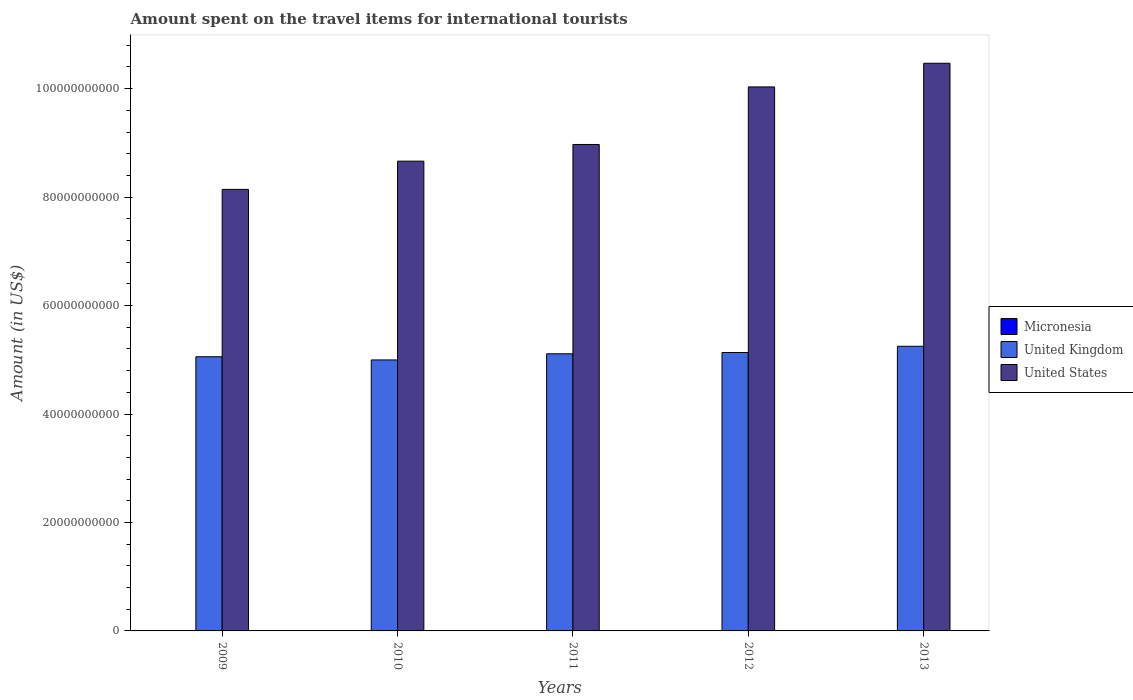How many groups of bars are there?
Provide a short and direct response. 5. How many bars are there on the 1st tick from the right?
Offer a very short reply. 3. In how many cases, is the number of bars for a given year not equal to the number of legend labels?
Provide a succinct answer. 0. What is the amount spent on the travel items for international tourists in United States in 2009?
Your answer should be compact. 8.14e+1. Across all years, what is the maximum amount spent on the travel items for international tourists in United Kingdom?
Your answer should be very brief. 5.25e+1. In which year was the amount spent on the travel items for international tourists in United States maximum?
Give a very brief answer. 2013. In which year was the amount spent on the travel items for international tourists in United Kingdom minimum?
Offer a very short reply. 2010. What is the total amount spent on the travel items for international tourists in United Kingdom in the graph?
Your answer should be compact. 2.55e+11. What is the difference between the amount spent on the travel items for international tourists in Micronesia in 2010 and the amount spent on the travel items for international tourists in United States in 2009?
Give a very brief answer. -8.14e+1. What is the average amount spent on the travel items for international tourists in United States per year?
Give a very brief answer. 9.25e+1. In the year 2009, what is the difference between the amount spent on the travel items for international tourists in United States and amount spent on the travel items for international tourists in United Kingdom?
Provide a succinct answer. 3.09e+1. In how many years, is the amount spent on the travel items for international tourists in United Kingdom greater than 56000000000 US$?
Offer a very short reply. 0. What is the ratio of the amount spent on the travel items for international tourists in United States in 2009 to that in 2010?
Offer a very short reply. 0.94. Is the amount spent on the travel items for international tourists in United Kingdom in 2009 less than that in 2013?
Keep it short and to the point. Yes. Is the difference between the amount spent on the travel items for international tourists in United States in 2011 and 2013 greater than the difference between the amount spent on the travel items for international tourists in United Kingdom in 2011 and 2013?
Keep it short and to the point. No. What is the difference between the highest and the second highest amount spent on the travel items for international tourists in United Kingdom?
Make the answer very short. 1.15e+09. What is the difference between the highest and the lowest amount spent on the travel items for international tourists in United Kingdom?
Provide a short and direct response. 2.52e+09. In how many years, is the amount spent on the travel items for international tourists in United States greater than the average amount spent on the travel items for international tourists in United States taken over all years?
Keep it short and to the point. 2. What does the 2nd bar from the left in 2011 represents?
Provide a succinct answer. United Kingdom. What does the 2nd bar from the right in 2010 represents?
Your answer should be compact. United Kingdom. How many years are there in the graph?
Make the answer very short. 5. What is the difference between two consecutive major ticks on the Y-axis?
Offer a terse response. 2.00e+1. Where does the legend appear in the graph?
Provide a succinct answer. Center right. How many legend labels are there?
Your answer should be compact. 3. How are the legend labels stacked?
Your response must be concise. Vertical. What is the title of the graph?
Your answer should be compact. Amount spent on the travel items for international tourists. Does "Slovak Republic" appear as one of the legend labels in the graph?
Offer a very short reply. No. What is the label or title of the X-axis?
Give a very brief answer. Years. What is the label or title of the Y-axis?
Provide a short and direct response. Amount (in US$). What is the Amount (in US$) in United Kingdom in 2009?
Your response must be concise. 5.06e+1. What is the Amount (in US$) of United States in 2009?
Your answer should be compact. 8.14e+1. What is the Amount (in US$) in Micronesia in 2010?
Offer a very short reply. 1.20e+07. What is the Amount (in US$) of United Kingdom in 2010?
Give a very brief answer. 5.00e+1. What is the Amount (in US$) in United States in 2010?
Your answer should be very brief. 8.66e+1. What is the Amount (in US$) in Micronesia in 2011?
Your answer should be compact. 1.20e+07. What is the Amount (in US$) of United Kingdom in 2011?
Your response must be concise. 5.11e+1. What is the Amount (in US$) of United States in 2011?
Your response must be concise. 8.97e+1. What is the Amount (in US$) in Micronesia in 2012?
Offer a terse response. 1.30e+07. What is the Amount (in US$) in United Kingdom in 2012?
Offer a terse response. 5.13e+1. What is the Amount (in US$) of United States in 2012?
Provide a short and direct response. 1.00e+11. What is the Amount (in US$) in Micronesia in 2013?
Give a very brief answer. 1.20e+07. What is the Amount (in US$) of United Kingdom in 2013?
Offer a very short reply. 5.25e+1. What is the Amount (in US$) in United States in 2013?
Your answer should be very brief. 1.05e+11. Across all years, what is the maximum Amount (in US$) of Micronesia?
Make the answer very short. 1.30e+07. Across all years, what is the maximum Amount (in US$) in United Kingdom?
Provide a short and direct response. 5.25e+1. Across all years, what is the maximum Amount (in US$) of United States?
Your answer should be compact. 1.05e+11. Across all years, what is the minimum Amount (in US$) of Micronesia?
Your answer should be compact. 1.00e+07. Across all years, what is the minimum Amount (in US$) in United Kingdom?
Your answer should be compact. 5.00e+1. Across all years, what is the minimum Amount (in US$) in United States?
Offer a terse response. 8.14e+1. What is the total Amount (in US$) in Micronesia in the graph?
Your response must be concise. 5.90e+07. What is the total Amount (in US$) of United Kingdom in the graph?
Your answer should be compact. 2.55e+11. What is the total Amount (in US$) of United States in the graph?
Ensure brevity in your answer.  4.63e+11. What is the difference between the Amount (in US$) in United Kingdom in 2009 and that in 2010?
Your answer should be compact. 5.87e+08. What is the difference between the Amount (in US$) of United States in 2009 and that in 2010?
Provide a short and direct response. -5.20e+09. What is the difference between the Amount (in US$) in Micronesia in 2009 and that in 2011?
Your answer should be compact. -2.00e+06. What is the difference between the Amount (in US$) in United Kingdom in 2009 and that in 2011?
Make the answer very short. -5.46e+08. What is the difference between the Amount (in US$) in United States in 2009 and that in 2011?
Keep it short and to the point. -8.28e+09. What is the difference between the Amount (in US$) in United Kingdom in 2009 and that in 2012?
Offer a very short reply. -7.82e+08. What is the difference between the Amount (in US$) in United States in 2009 and that in 2012?
Give a very brief answer. -1.89e+1. What is the difference between the Amount (in US$) of Micronesia in 2009 and that in 2013?
Your response must be concise. -2.00e+06. What is the difference between the Amount (in US$) in United Kingdom in 2009 and that in 2013?
Ensure brevity in your answer.  -1.93e+09. What is the difference between the Amount (in US$) in United States in 2009 and that in 2013?
Give a very brief answer. -2.33e+1. What is the difference between the Amount (in US$) in United Kingdom in 2010 and that in 2011?
Your answer should be compact. -1.13e+09. What is the difference between the Amount (in US$) in United States in 2010 and that in 2011?
Provide a succinct answer. -3.08e+09. What is the difference between the Amount (in US$) in United Kingdom in 2010 and that in 2012?
Offer a terse response. -1.37e+09. What is the difference between the Amount (in US$) of United States in 2010 and that in 2012?
Your answer should be very brief. -1.37e+1. What is the difference between the Amount (in US$) in United Kingdom in 2010 and that in 2013?
Your answer should be compact. -2.52e+09. What is the difference between the Amount (in US$) of United States in 2010 and that in 2013?
Ensure brevity in your answer.  -1.81e+1. What is the difference between the Amount (in US$) of Micronesia in 2011 and that in 2012?
Offer a terse response. -1.00e+06. What is the difference between the Amount (in US$) in United Kingdom in 2011 and that in 2012?
Offer a terse response. -2.36e+08. What is the difference between the Amount (in US$) of United States in 2011 and that in 2012?
Make the answer very short. -1.06e+1. What is the difference between the Amount (in US$) in Micronesia in 2011 and that in 2013?
Offer a very short reply. 0. What is the difference between the Amount (in US$) in United Kingdom in 2011 and that in 2013?
Your response must be concise. -1.38e+09. What is the difference between the Amount (in US$) of United States in 2011 and that in 2013?
Your answer should be very brief. -1.50e+1. What is the difference between the Amount (in US$) of Micronesia in 2012 and that in 2013?
Offer a very short reply. 1.00e+06. What is the difference between the Amount (in US$) in United Kingdom in 2012 and that in 2013?
Make the answer very short. -1.15e+09. What is the difference between the Amount (in US$) of United States in 2012 and that in 2013?
Your response must be concise. -4.36e+09. What is the difference between the Amount (in US$) of Micronesia in 2009 and the Amount (in US$) of United Kingdom in 2010?
Offer a very short reply. -5.00e+1. What is the difference between the Amount (in US$) in Micronesia in 2009 and the Amount (in US$) in United States in 2010?
Provide a succinct answer. -8.66e+1. What is the difference between the Amount (in US$) of United Kingdom in 2009 and the Amount (in US$) of United States in 2010?
Ensure brevity in your answer.  -3.61e+1. What is the difference between the Amount (in US$) in Micronesia in 2009 and the Amount (in US$) in United Kingdom in 2011?
Make the answer very short. -5.11e+1. What is the difference between the Amount (in US$) in Micronesia in 2009 and the Amount (in US$) in United States in 2011?
Provide a short and direct response. -8.97e+1. What is the difference between the Amount (in US$) in United Kingdom in 2009 and the Amount (in US$) in United States in 2011?
Give a very brief answer. -3.91e+1. What is the difference between the Amount (in US$) in Micronesia in 2009 and the Amount (in US$) in United Kingdom in 2012?
Make the answer very short. -5.13e+1. What is the difference between the Amount (in US$) of Micronesia in 2009 and the Amount (in US$) of United States in 2012?
Offer a terse response. -1.00e+11. What is the difference between the Amount (in US$) in United Kingdom in 2009 and the Amount (in US$) in United States in 2012?
Your answer should be compact. -4.98e+1. What is the difference between the Amount (in US$) in Micronesia in 2009 and the Amount (in US$) in United Kingdom in 2013?
Your answer should be very brief. -5.25e+1. What is the difference between the Amount (in US$) of Micronesia in 2009 and the Amount (in US$) of United States in 2013?
Provide a short and direct response. -1.05e+11. What is the difference between the Amount (in US$) of United Kingdom in 2009 and the Amount (in US$) of United States in 2013?
Your answer should be compact. -5.41e+1. What is the difference between the Amount (in US$) of Micronesia in 2010 and the Amount (in US$) of United Kingdom in 2011?
Your response must be concise. -5.11e+1. What is the difference between the Amount (in US$) in Micronesia in 2010 and the Amount (in US$) in United States in 2011?
Provide a short and direct response. -8.97e+1. What is the difference between the Amount (in US$) in United Kingdom in 2010 and the Amount (in US$) in United States in 2011?
Give a very brief answer. -3.97e+1. What is the difference between the Amount (in US$) of Micronesia in 2010 and the Amount (in US$) of United Kingdom in 2012?
Make the answer very short. -5.13e+1. What is the difference between the Amount (in US$) of Micronesia in 2010 and the Amount (in US$) of United States in 2012?
Give a very brief answer. -1.00e+11. What is the difference between the Amount (in US$) in United Kingdom in 2010 and the Amount (in US$) in United States in 2012?
Your response must be concise. -5.03e+1. What is the difference between the Amount (in US$) of Micronesia in 2010 and the Amount (in US$) of United Kingdom in 2013?
Your response must be concise. -5.25e+1. What is the difference between the Amount (in US$) in Micronesia in 2010 and the Amount (in US$) in United States in 2013?
Your answer should be very brief. -1.05e+11. What is the difference between the Amount (in US$) of United Kingdom in 2010 and the Amount (in US$) of United States in 2013?
Keep it short and to the point. -5.47e+1. What is the difference between the Amount (in US$) of Micronesia in 2011 and the Amount (in US$) of United Kingdom in 2012?
Provide a succinct answer. -5.13e+1. What is the difference between the Amount (in US$) of Micronesia in 2011 and the Amount (in US$) of United States in 2012?
Your answer should be very brief. -1.00e+11. What is the difference between the Amount (in US$) in United Kingdom in 2011 and the Amount (in US$) in United States in 2012?
Your response must be concise. -4.92e+1. What is the difference between the Amount (in US$) in Micronesia in 2011 and the Amount (in US$) in United Kingdom in 2013?
Your answer should be compact. -5.25e+1. What is the difference between the Amount (in US$) in Micronesia in 2011 and the Amount (in US$) in United States in 2013?
Provide a succinct answer. -1.05e+11. What is the difference between the Amount (in US$) of United Kingdom in 2011 and the Amount (in US$) of United States in 2013?
Ensure brevity in your answer.  -5.36e+1. What is the difference between the Amount (in US$) of Micronesia in 2012 and the Amount (in US$) of United Kingdom in 2013?
Your answer should be very brief. -5.25e+1. What is the difference between the Amount (in US$) in Micronesia in 2012 and the Amount (in US$) in United States in 2013?
Give a very brief answer. -1.05e+11. What is the difference between the Amount (in US$) of United Kingdom in 2012 and the Amount (in US$) of United States in 2013?
Ensure brevity in your answer.  -5.33e+1. What is the average Amount (in US$) in Micronesia per year?
Ensure brevity in your answer.  1.18e+07. What is the average Amount (in US$) of United Kingdom per year?
Provide a succinct answer. 5.11e+1. What is the average Amount (in US$) of United States per year?
Your answer should be compact. 9.25e+1. In the year 2009, what is the difference between the Amount (in US$) of Micronesia and Amount (in US$) of United Kingdom?
Offer a very short reply. -5.05e+1. In the year 2009, what is the difference between the Amount (in US$) in Micronesia and Amount (in US$) in United States?
Your answer should be very brief. -8.14e+1. In the year 2009, what is the difference between the Amount (in US$) of United Kingdom and Amount (in US$) of United States?
Ensure brevity in your answer.  -3.09e+1. In the year 2010, what is the difference between the Amount (in US$) of Micronesia and Amount (in US$) of United Kingdom?
Your answer should be compact. -5.00e+1. In the year 2010, what is the difference between the Amount (in US$) in Micronesia and Amount (in US$) in United States?
Your response must be concise. -8.66e+1. In the year 2010, what is the difference between the Amount (in US$) of United Kingdom and Amount (in US$) of United States?
Ensure brevity in your answer.  -3.67e+1. In the year 2011, what is the difference between the Amount (in US$) of Micronesia and Amount (in US$) of United Kingdom?
Your answer should be compact. -5.11e+1. In the year 2011, what is the difference between the Amount (in US$) in Micronesia and Amount (in US$) in United States?
Offer a terse response. -8.97e+1. In the year 2011, what is the difference between the Amount (in US$) of United Kingdom and Amount (in US$) of United States?
Give a very brief answer. -3.86e+1. In the year 2012, what is the difference between the Amount (in US$) of Micronesia and Amount (in US$) of United Kingdom?
Offer a terse response. -5.13e+1. In the year 2012, what is the difference between the Amount (in US$) in Micronesia and Amount (in US$) in United States?
Give a very brief answer. -1.00e+11. In the year 2012, what is the difference between the Amount (in US$) in United Kingdom and Amount (in US$) in United States?
Ensure brevity in your answer.  -4.90e+1. In the year 2013, what is the difference between the Amount (in US$) of Micronesia and Amount (in US$) of United Kingdom?
Your answer should be very brief. -5.25e+1. In the year 2013, what is the difference between the Amount (in US$) of Micronesia and Amount (in US$) of United States?
Make the answer very short. -1.05e+11. In the year 2013, what is the difference between the Amount (in US$) of United Kingdom and Amount (in US$) of United States?
Your response must be concise. -5.22e+1. What is the ratio of the Amount (in US$) of United Kingdom in 2009 to that in 2010?
Provide a short and direct response. 1.01. What is the ratio of the Amount (in US$) in United States in 2009 to that in 2010?
Your answer should be very brief. 0.94. What is the ratio of the Amount (in US$) of United Kingdom in 2009 to that in 2011?
Offer a terse response. 0.99. What is the ratio of the Amount (in US$) in United States in 2009 to that in 2011?
Give a very brief answer. 0.91. What is the ratio of the Amount (in US$) of Micronesia in 2009 to that in 2012?
Your answer should be very brief. 0.77. What is the ratio of the Amount (in US$) of United States in 2009 to that in 2012?
Your response must be concise. 0.81. What is the ratio of the Amount (in US$) of United Kingdom in 2009 to that in 2013?
Offer a terse response. 0.96. What is the ratio of the Amount (in US$) of Micronesia in 2010 to that in 2011?
Provide a succinct answer. 1. What is the ratio of the Amount (in US$) of United Kingdom in 2010 to that in 2011?
Your answer should be compact. 0.98. What is the ratio of the Amount (in US$) in United States in 2010 to that in 2011?
Offer a terse response. 0.97. What is the ratio of the Amount (in US$) in Micronesia in 2010 to that in 2012?
Ensure brevity in your answer.  0.92. What is the ratio of the Amount (in US$) of United Kingdom in 2010 to that in 2012?
Your response must be concise. 0.97. What is the ratio of the Amount (in US$) in United States in 2010 to that in 2012?
Offer a very short reply. 0.86. What is the ratio of the Amount (in US$) in Micronesia in 2010 to that in 2013?
Offer a terse response. 1. What is the ratio of the Amount (in US$) in United States in 2010 to that in 2013?
Provide a short and direct response. 0.83. What is the ratio of the Amount (in US$) in United States in 2011 to that in 2012?
Provide a short and direct response. 0.89. What is the ratio of the Amount (in US$) of Micronesia in 2011 to that in 2013?
Make the answer very short. 1. What is the ratio of the Amount (in US$) in United Kingdom in 2011 to that in 2013?
Provide a short and direct response. 0.97. What is the ratio of the Amount (in US$) in United States in 2011 to that in 2013?
Offer a terse response. 0.86. What is the ratio of the Amount (in US$) in United Kingdom in 2012 to that in 2013?
Your response must be concise. 0.98. What is the difference between the highest and the second highest Amount (in US$) of United Kingdom?
Give a very brief answer. 1.15e+09. What is the difference between the highest and the second highest Amount (in US$) of United States?
Provide a succinct answer. 4.36e+09. What is the difference between the highest and the lowest Amount (in US$) of Micronesia?
Keep it short and to the point. 3.00e+06. What is the difference between the highest and the lowest Amount (in US$) of United Kingdom?
Keep it short and to the point. 2.52e+09. What is the difference between the highest and the lowest Amount (in US$) in United States?
Keep it short and to the point. 2.33e+1. 